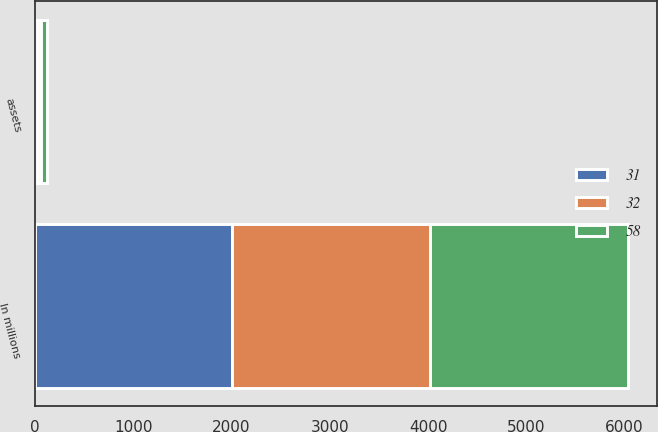Convert chart. <chart><loc_0><loc_0><loc_500><loc_500><stacked_bar_chart><ecel><fcel>In millions<fcel>assets<nl><fcel>58<fcel>2012<fcel>58<nl><fcel>32<fcel>2011<fcel>32<nl><fcel>31<fcel>2010<fcel>31<nl></chart> 